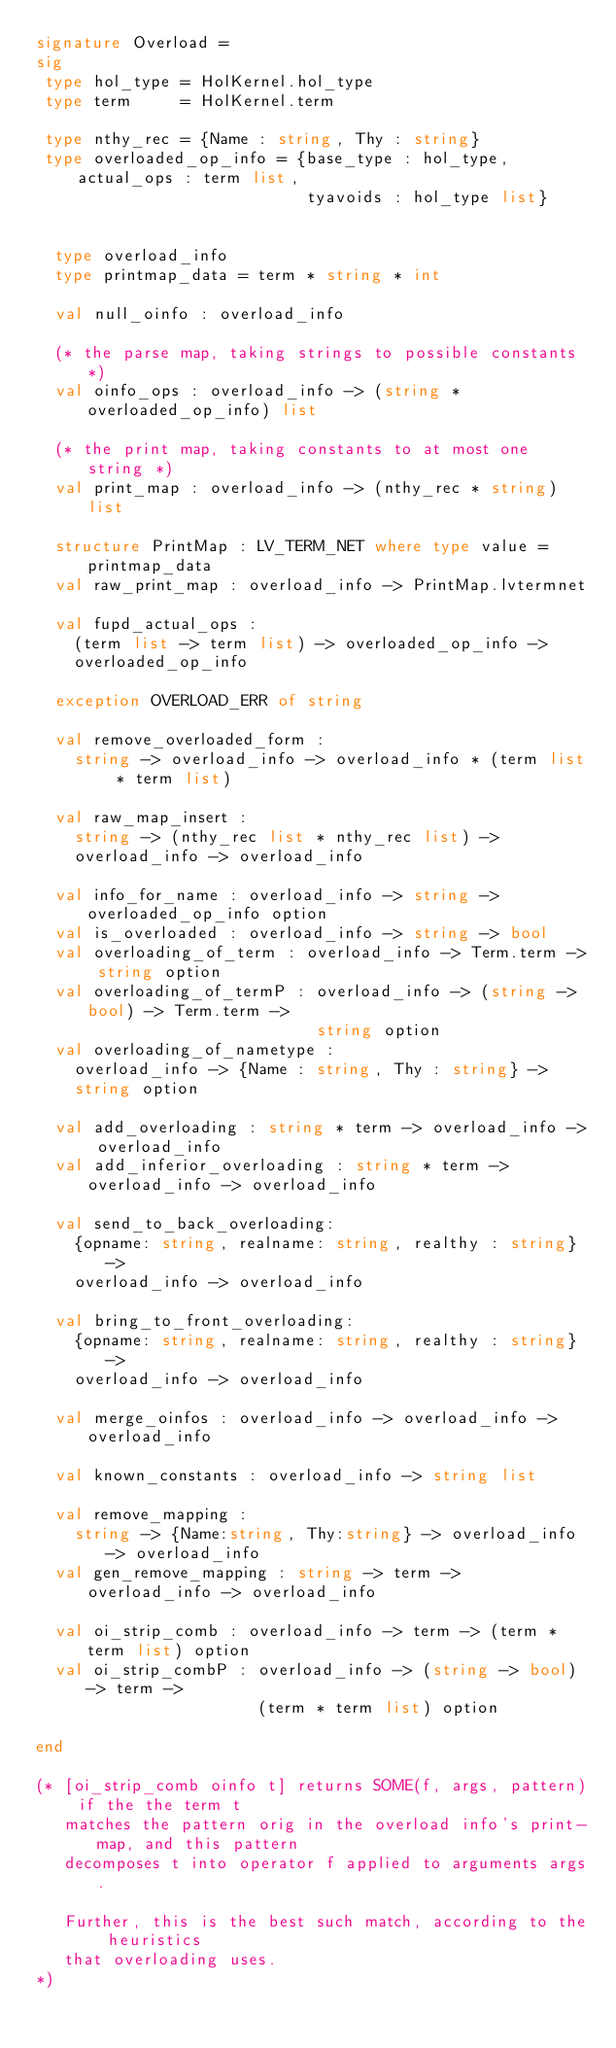<code> <loc_0><loc_0><loc_500><loc_500><_SML_>signature Overload =
sig
 type hol_type = HolKernel.hol_type
 type term     = HolKernel.term

 type nthy_rec = {Name : string, Thy : string}
 type overloaded_op_info = {base_type : hol_type, actual_ops : term list,
                            tyavoids : hol_type list}


  type overload_info
  type printmap_data = term * string * int

  val null_oinfo : overload_info

  (* the parse map, taking strings to possible constants *)
  val oinfo_ops : overload_info -> (string * overloaded_op_info) list

  (* the print map, taking constants to at most one string *)
  val print_map : overload_info -> (nthy_rec * string) list

  structure PrintMap : LV_TERM_NET where type value = printmap_data
  val raw_print_map : overload_info -> PrintMap.lvtermnet

  val fupd_actual_ops :
    (term list -> term list) -> overloaded_op_info ->
    overloaded_op_info

  exception OVERLOAD_ERR of string

  val remove_overloaded_form :
    string -> overload_info -> overload_info * (term list * term list)

  val raw_map_insert :
    string -> (nthy_rec list * nthy_rec list) ->
    overload_info -> overload_info

  val info_for_name : overload_info -> string -> overloaded_op_info option
  val is_overloaded : overload_info -> string -> bool
  val overloading_of_term : overload_info -> Term.term -> string option
  val overloading_of_termP : overload_info -> (string -> bool) -> Term.term ->
                             string option
  val overloading_of_nametype :
    overload_info -> {Name : string, Thy : string} ->
    string option

  val add_overloading : string * term -> overload_info -> overload_info
  val add_inferior_overloading : string * term -> overload_info -> overload_info

  val send_to_back_overloading:
    {opname: string, realname: string, realthy : string} ->
    overload_info -> overload_info

  val bring_to_front_overloading:
    {opname: string, realname: string, realthy : string} ->
    overload_info -> overload_info

  val merge_oinfos : overload_info -> overload_info -> overload_info

  val known_constants : overload_info -> string list

  val remove_mapping :
    string -> {Name:string, Thy:string} -> overload_info -> overload_info
  val gen_remove_mapping : string -> term -> overload_info -> overload_info

  val oi_strip_comb : overload_info -> term -> (term * term list) option
  val oi_strip_combP : overload_info -> (string -> bool) -> term ->
                       (term * term list) option

end

(* [oi_strip_comb oinfo t] returns SOME(f, args, pattern) if the the term t
   matches the pattern orig in the overload info's print-map, and this pattern
   decomposes t into operator f applied to arguments args.

   Further, this is the best such match, according to the heuristics
   that overloading uses.
*)
</code> 